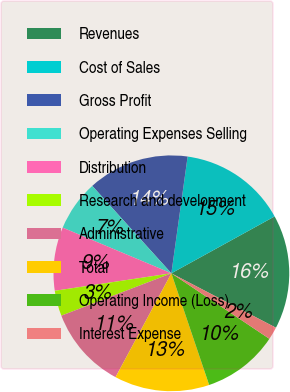Convert chart. <chart><loc_0><loc_0><loc_500><loc_500><pie_chart><fcel>Revenues<fcel>Cost of Sales<fcel>Gross Profit<fcel>Operating Expenses Selling<fcel>Distribution<fcel>Research and development<fcel>Administrative<fcel>Total<fcel>Operating Income (Loss)<fcel>Interest Expense<nl><fcel>15.65%<fcel>14.78%<fcel>13.91%<fcel>6.96%<fcel>8.7%<fcel>3.48%<fcel>11.3%<fcel>13.04%<fcel>10.43%<fcel>1.74%<nl></chart> 